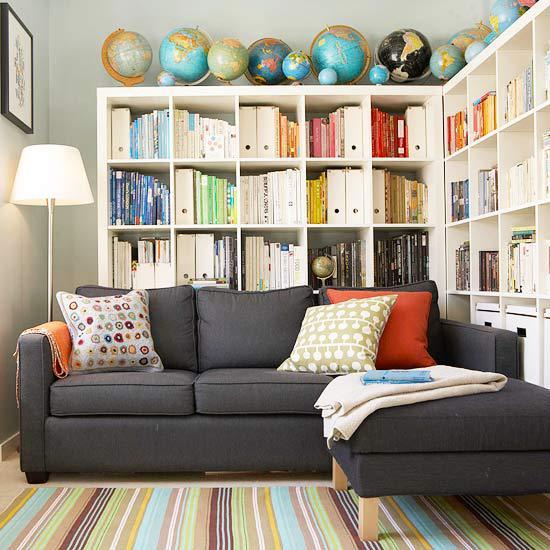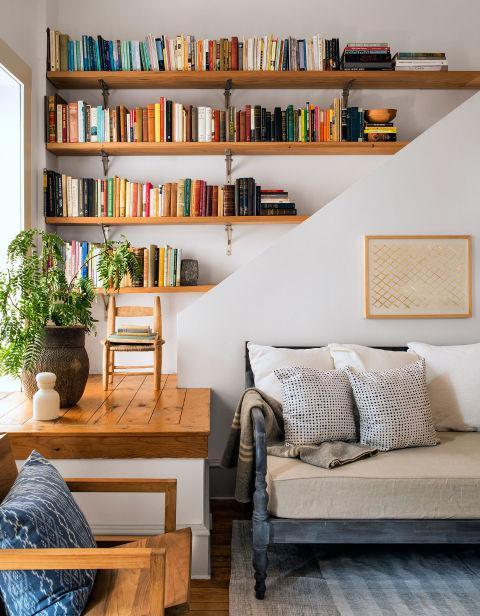The first image is the image on the left, the second image is the image on the right. For the images displayed, is the sentence "In one image, a seating area is in front of an interior doorway that is surrounded by bookcases." factually correct? Answer yes or no. No. The first image is the image on the left, the second image is the image on the right. Assess this claim about the two images: "In at least one image the white bookshelf has squaded shelves.". Correct or not? Answer yes or no. Yes. 